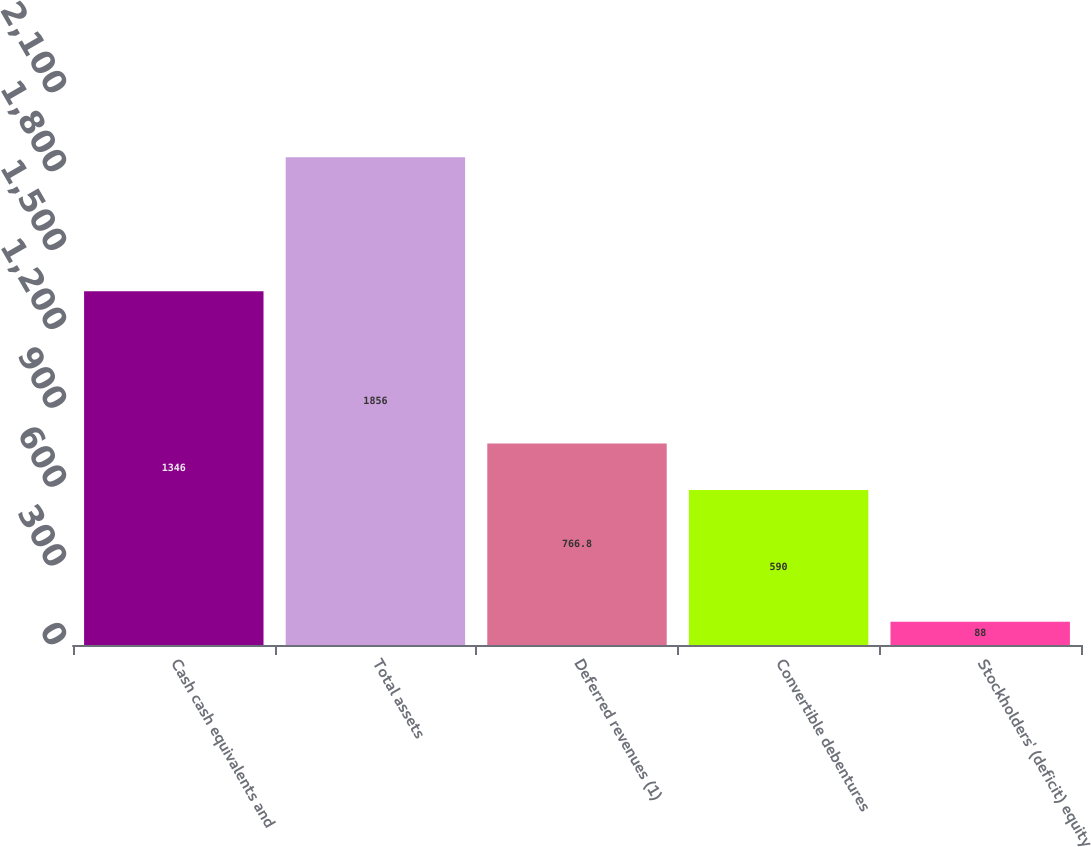Convert chart. <chart><loc_0><loc_0><loc_500><loc_500><bar_chart><fcel>Cash cash equivalents and<fcel>Total assets<fcel>Deferred revenues (1)<fcel>Convertible debentures<fcel>Stockholders' (deficit) equity<nl><fcel>1346<fcel>1856<fcel>766.8<fcel>590<fcel>88<nl></chart> 